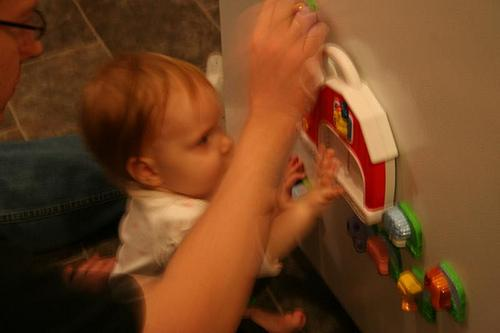Express the primary subjects and their doings in the image in a casual manner. So there's this baby having fun with toys, and a person wearing glasses is holding the little one. Mention the two primary subjects in the display along with their actions. A baby playing with toys and a person with glasses holding the baby. Please give a concise description of what the main figures in the picture are up to. A bespectacled person is holding a playful baby who is occupied with toys. In a phrase consisting of two parts joined by "and," describe the main subjects and their actions in the image. A baby delighting in toys, and a person with glasses cradling them. Write a brief narrative describing the main activity taking place in the image. A scene unfolds with a baby entertained by toys, while being held by an adult wearing glasses. State the main subjects and their actions in the image using an informal tone. A cute baby's playing with toys, and there's this person with glasses holding them. Describe the main subjects in the image and their actions in the present continuous tense. A baby is playing with toys and a person is wearing glasses and holding the baby. Make a statement describing the primary elements in the picture along with the actions of the people. In the image, a baby is engaged with toys while a person wearing glasses holds them. In simple words, explain the primary objects in the image as well as the people's actions. There is a baby playing with toys and a person with glasses holding the baby. Using passive voice, explain the primary subjects in the image and their activities. A baby being held by a person with glasses is seen playing with toys. 